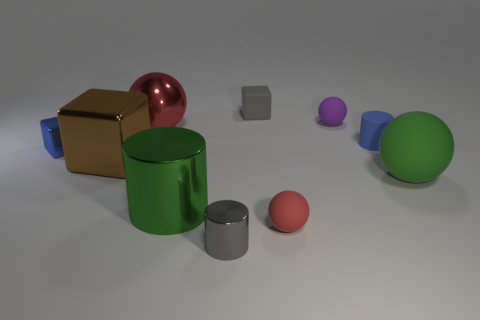Subtract all tiny cubes. How many cubes are left? 1 Subtract 1 cylinders. How many cylinders are left? 2 Subtract all red spheres. How many spheres are left? 2 Add 6 red metal spheres. How many red metal spheres exist? 7 Subtract 0 brown cylinders. How many objects are left? 10 Subtract all balls. How many objects are left? 6 Subtract all purple spheres. Subtract all yellow cubes. How many spheres are left? 3 Subtract all red cubes. How many green balls are left? 1 Subtract all large spheres. Subtract all big green objects. How many objects are left? 6 Add 5 red balls. How many red balls are left? 7 